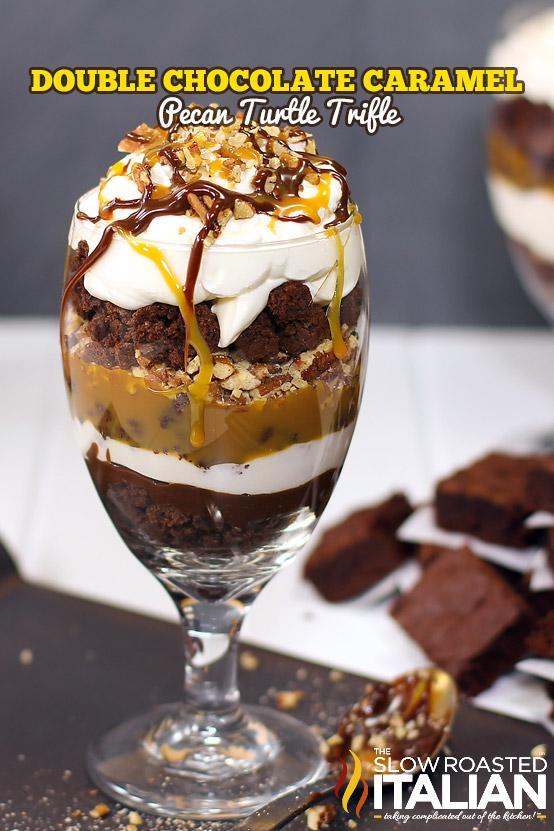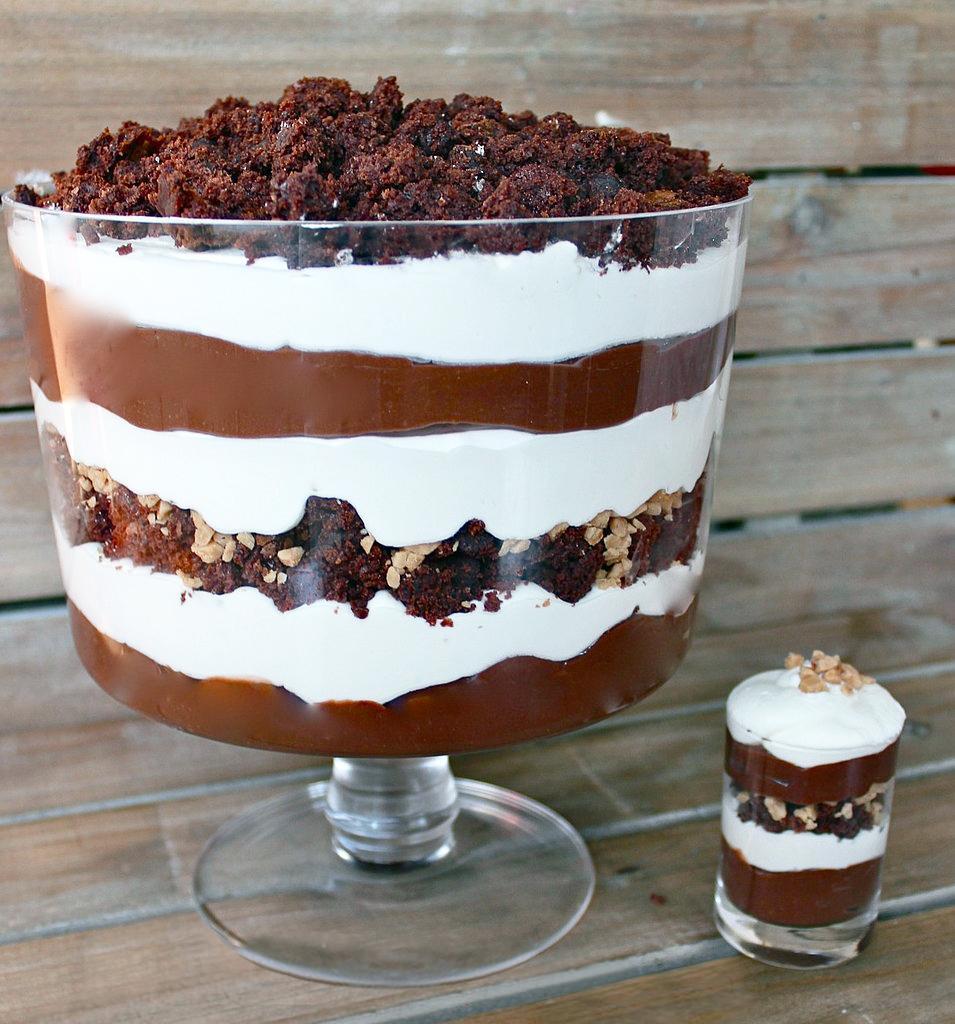The first image is the image on the left, the second image is the image on the right. Considering the images on both sides, is "An image shows a layered dessert in a footed glass sitting directly on wood furniture." valid? Answer yes or no. Yes. The first image is the image on the left, the second image is the image on the right. Considering the images on both sides, is "Exactly two large trifle desserts in clear footed bowls are shown, one made with chocolate layers and one made with strawberries." valid? Answer yes or no. No. 